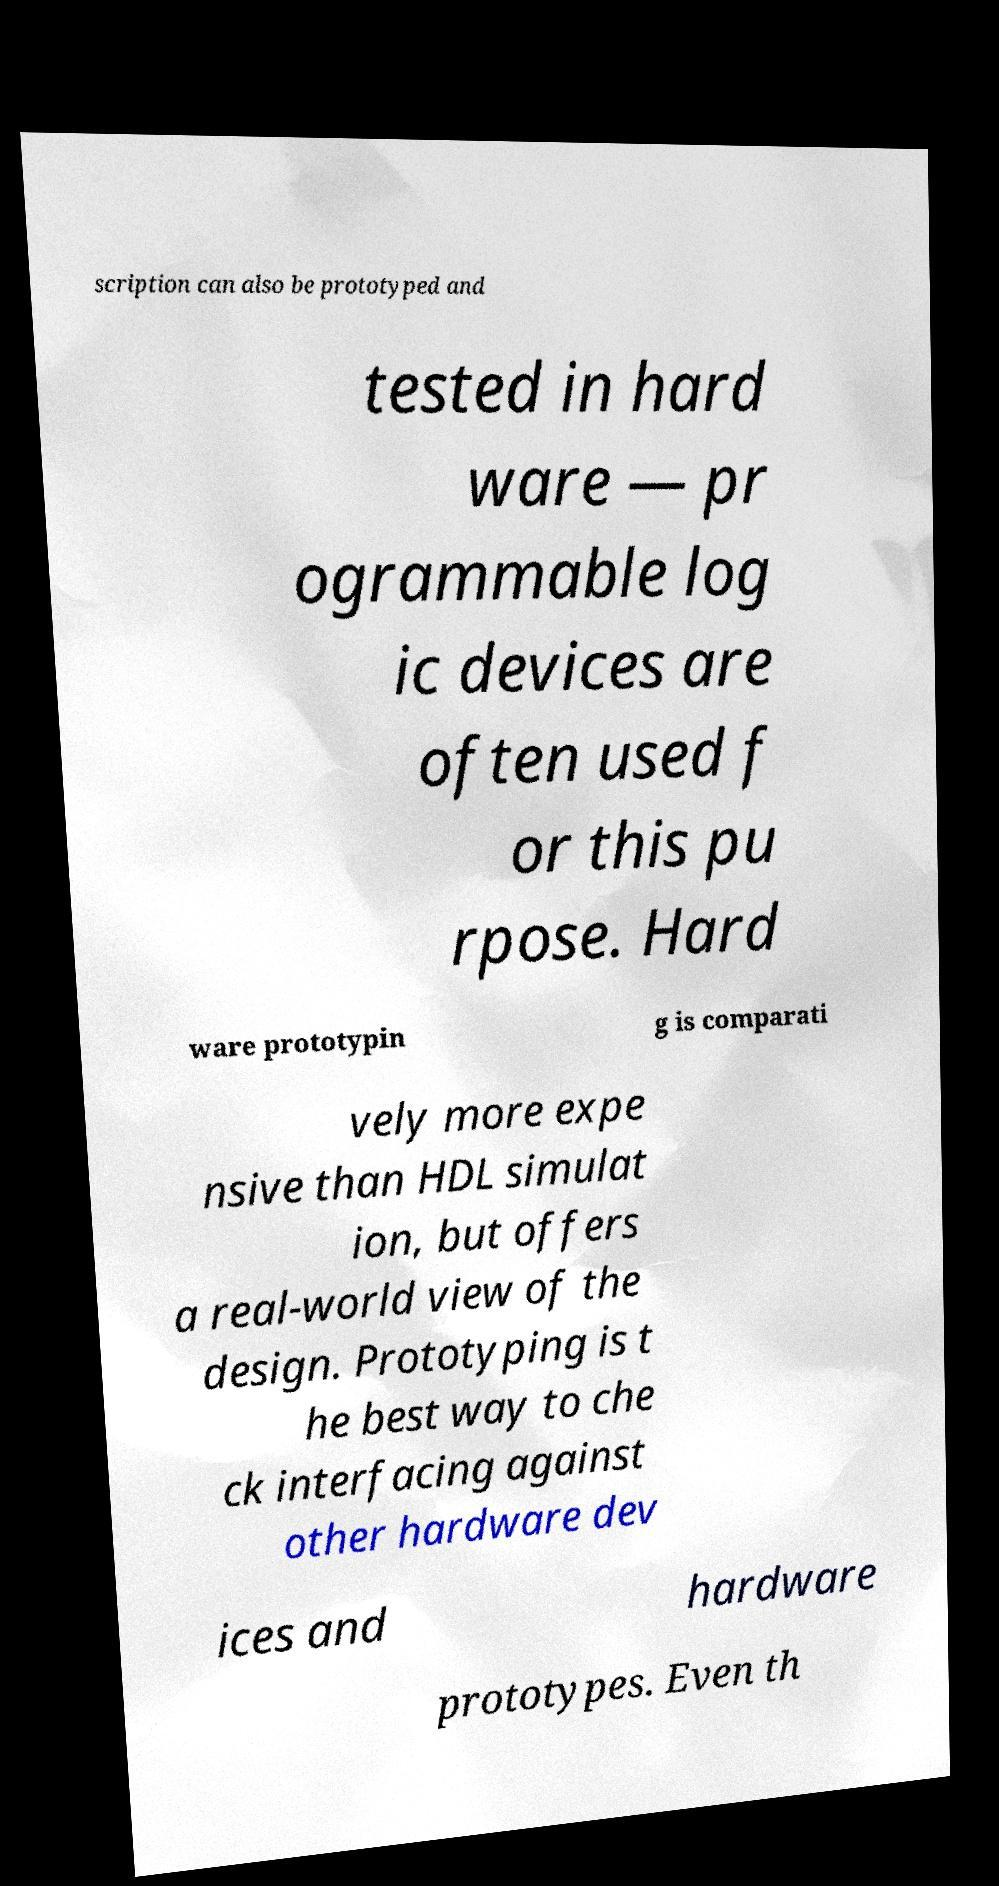For documentation purposes, I need the text within this image transcribed. Could you provide that? scription can also be prototyped and tested in hard ware — pr ogrammable log ic devices are often used f or this pu rpose. Hard ware prototypin g is comparati vely more expe nsive than HDL simulat ion, but offers a real-world view of the design. Prototyping is t he best way to che ck interfacing against other hardware dev ices and hardware prototypes. Even th 